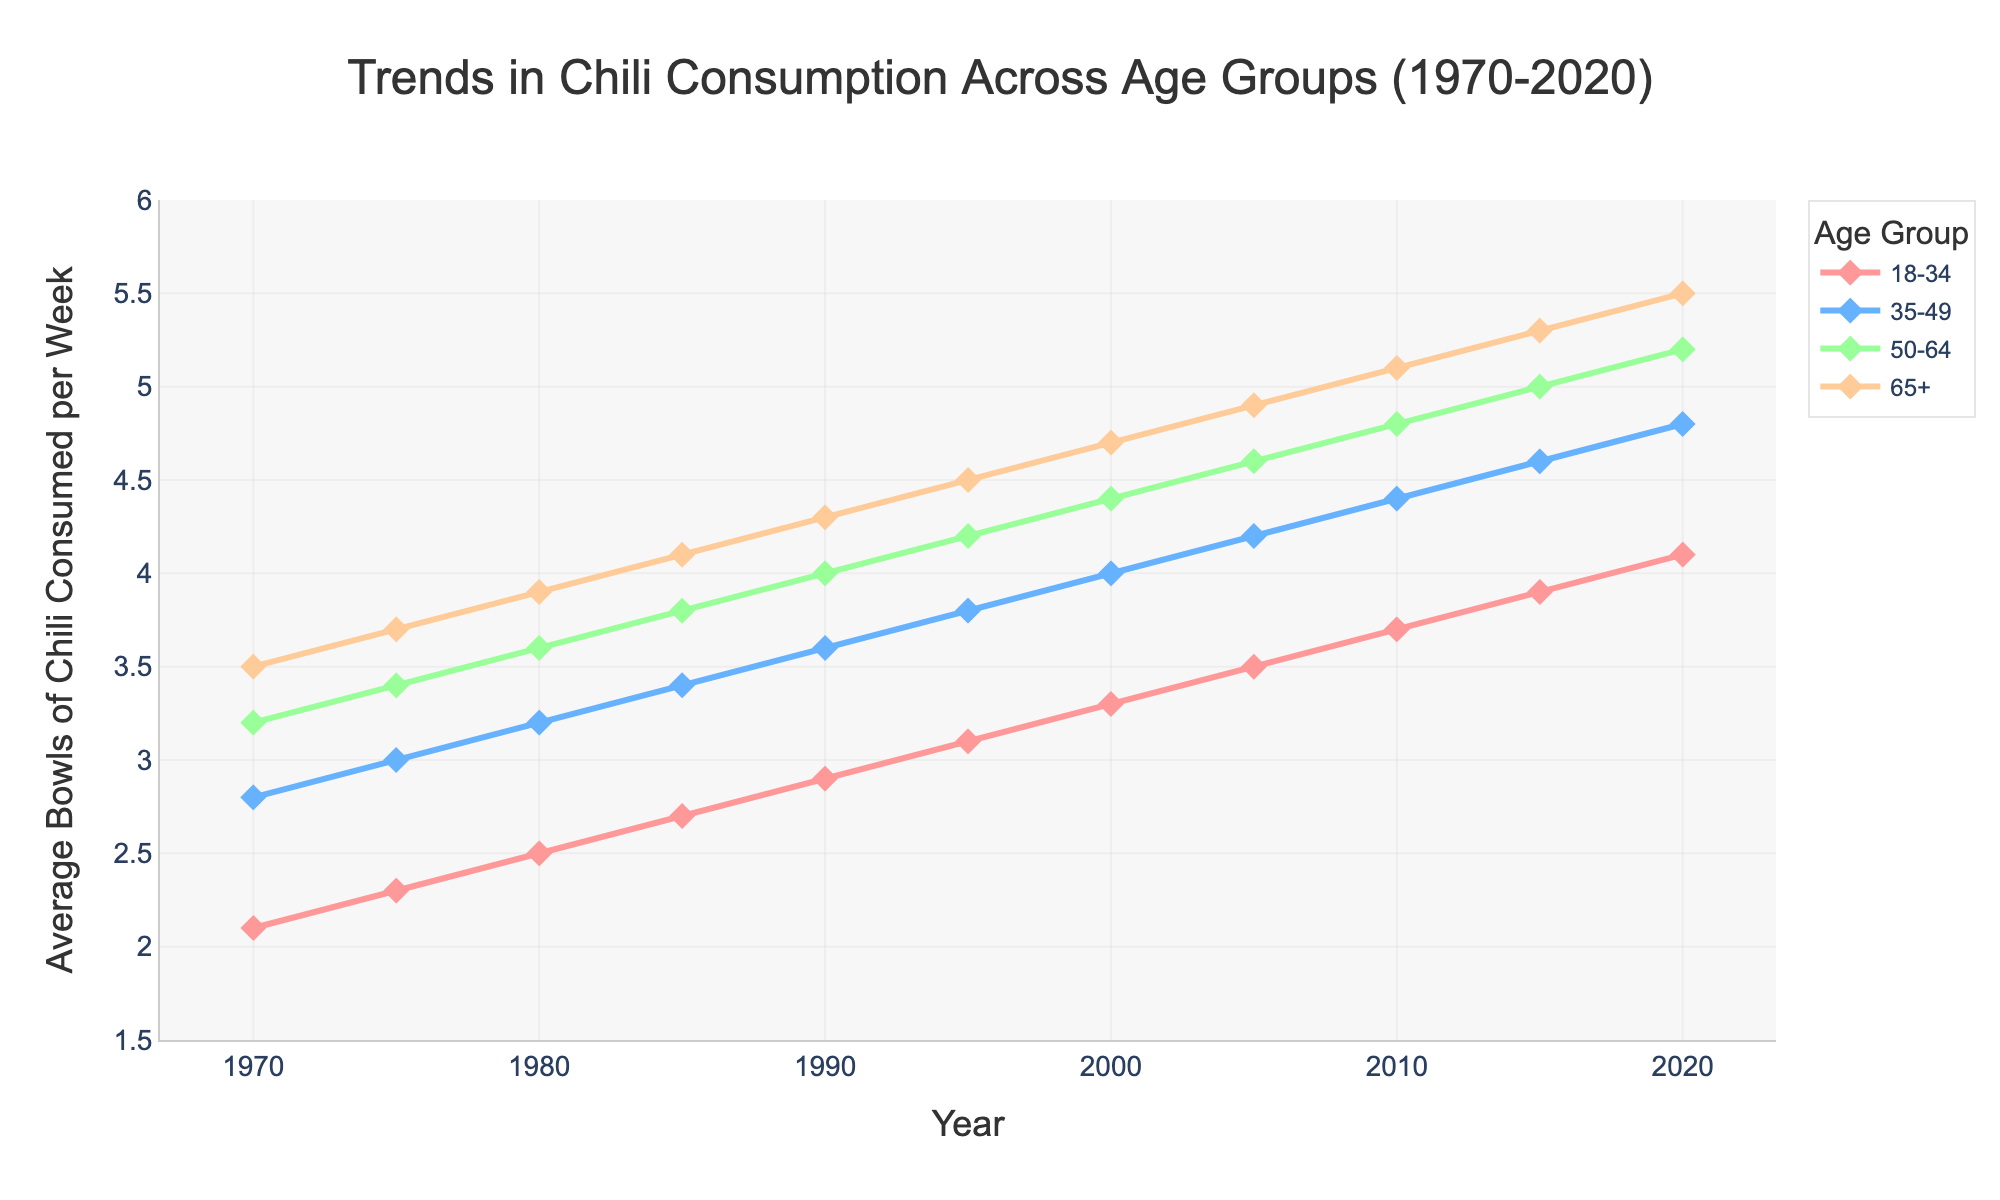Which age group had the highest chili consumption in 1980? Look at the year 1980 on the x-axis, then find the highest y-value among all age groups by examining the lines and markers.
Answer: 65+ What is the difference in chili consumption between the 18-34 and 65+ age groups in 2020? Identify the chili consumption values for both the 18-34 and 65+ age groups in the year 2020 and subtract the former from the latter.
Answer: 1.4 How did chili consumption for the 35-49 age group change from 1975 to 2000? Find the values for the 35-49 age group in the years 1975 and 2000, then calculate the difference.
Answer: Increased by 1.0 Which age group shows the steepest increase in chili consumption over the entire period from 1970 to 2020? Compare the overall slopes of the lines for each age group from 1970 to 2020 and identify the steepest one.
Answer: 18-34 What is the average chili consumption for the 50-64 age group over the 50 years? Sum the chili consumption values for the 50-64 age group over all years and divide by the number of years (11 data points).
Answer: 4.2 In which decade did the 65+ age group see the smallest increase in chili consumption? Compare the increments in chili consumption for the 65+ age group across each decade by subtracting the start-of-decade value from the end-of-decade value.
Answer: 1980s How does the chili consumption trend from 2000 to 2020 compare between the 18-34 and 35-49 age groups? Identify the trends (slopes of the lines) for both age groups between 2000 and 2020 and compare their steepness.
Answer: Both increased, 18-34 more steeply What color represents the 50-64 age group in the plot? Look at the legend on the plot and find the color corresponding to the 50-64 age group.
Answer: Green Which age group shows the smallest overall change in chili consumption from 1970 to 2020? Calculate the overall change in chili consumption from 1970 to 2020 for each age group and identify the smallest change.
Answer: 35-49 